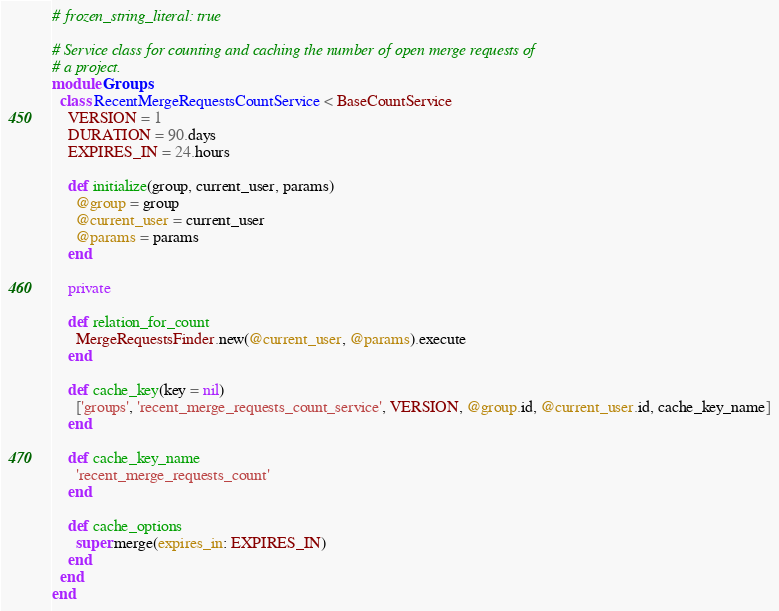<code> <loc_0><loc_0><loc_500><loc_500><_Ruby_># frozen_string_literal: true

# Service class for counting and caching the number of open merge requests of
# a project.
module Groups
  class RecentMergeRequestsCountService < BaseCountService
    VERSION = 1
    DURATION = 90.days
    EXPIRES_IN = 24.hours

    def initialize(group, current_user, params)
      @group = group
      @current_user = current_user
      @params = params
    end

    private

    def relation_for_count
      MergeRequestsFinder.new(@current_user, @params).execute
    end

    def cache_key(key = nil)
      ['groups', 'recent_merge_requests_count_service', VERSION, @group.id, @current_user.id, cache_key_name]
    end

    def cache_key_name
      'recent_merge_requests_count'
    end

    def cache_options
      super.merge(expires_in: EXPIRES_IN)
    end
  end
end
</code> 